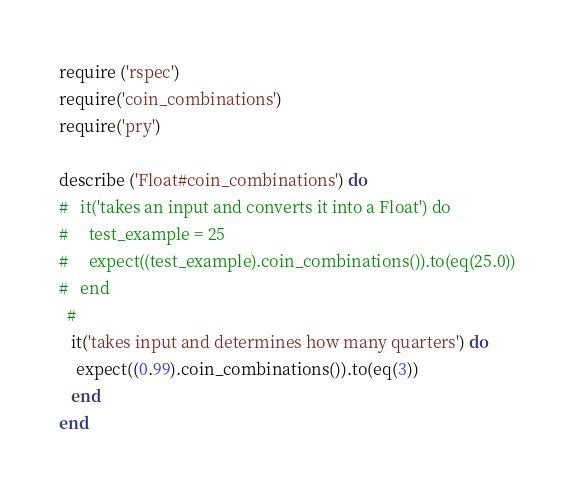<code> <loc_0><loc_0><loc_500><loc_500><_Ruby_>require ('rspec')
require('coin_combinations')
require('pry')

describe ('Float#coin_combinations') do
#   it('takes an input and converts it into a Float') do
#     test_example = 25
#     expect((test_example).coin_combinations()).to(eq(25.0))
#   end
  #
   it('takes input and determines how many quarters') do
    expect((0.99).coin_combinations()).to(eq(3))
   end
end
</code> 